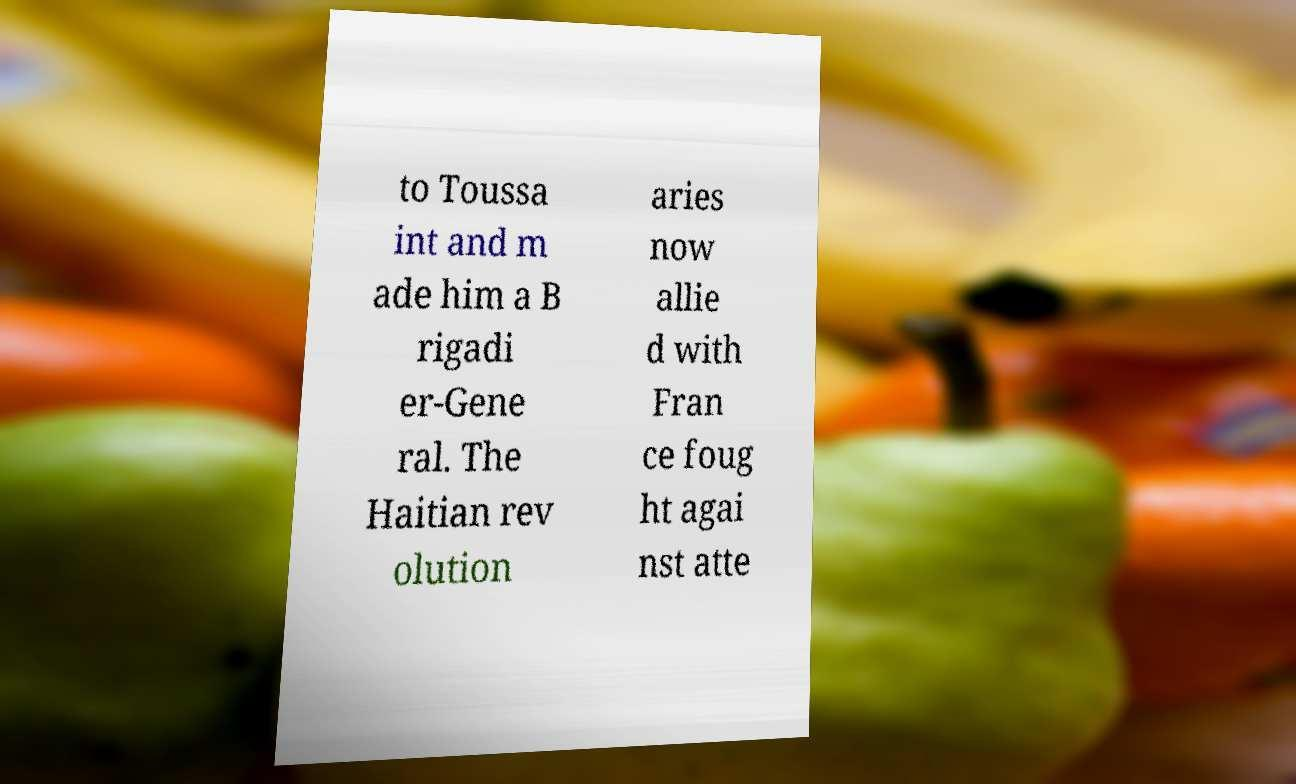I need the written content from this picture converted into text. Can you do that? to Toussa int and m ade him a B rigadi er-Gene ral. The Haitian rev olution aries now allie d with Fran ce foug ht agai nst atte 